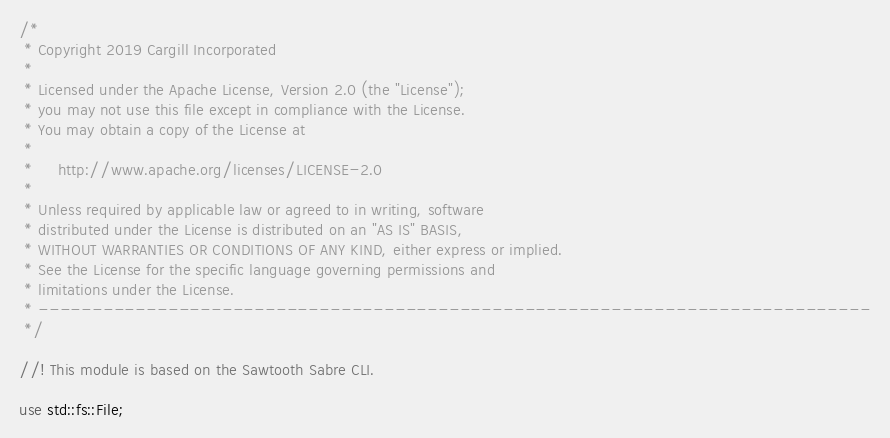<code> <loc_0><loc_0><loc_500><loc_500><_Rust_>/*
 * Copyright 2019 Cargill Incorporated
 *
 * Licensed under the Apache License, Version 2.0 (the "License");
 * you may not use this file except in compliance with the License.
 * You may obtain a copy of the License at
 *
 *     http://www.apache.org/licenses/LICENSE-2.0
 *
 * Unless required by applicable law or agreed to in writing, software
 * distributed under the License is distributed on an "AS IS" BASIS,
 * WITHOUT WARRANTIES OR CONDITIONS OF ANY KIND, either express or implied.
 * See the License for the specific language governing permissions and
 * limitations under the License.
 * -----------------------------------------------------------------------------
 */

//! This module is based on the Sawtooth Sabre CLI.

use std::fs::File;</code> 